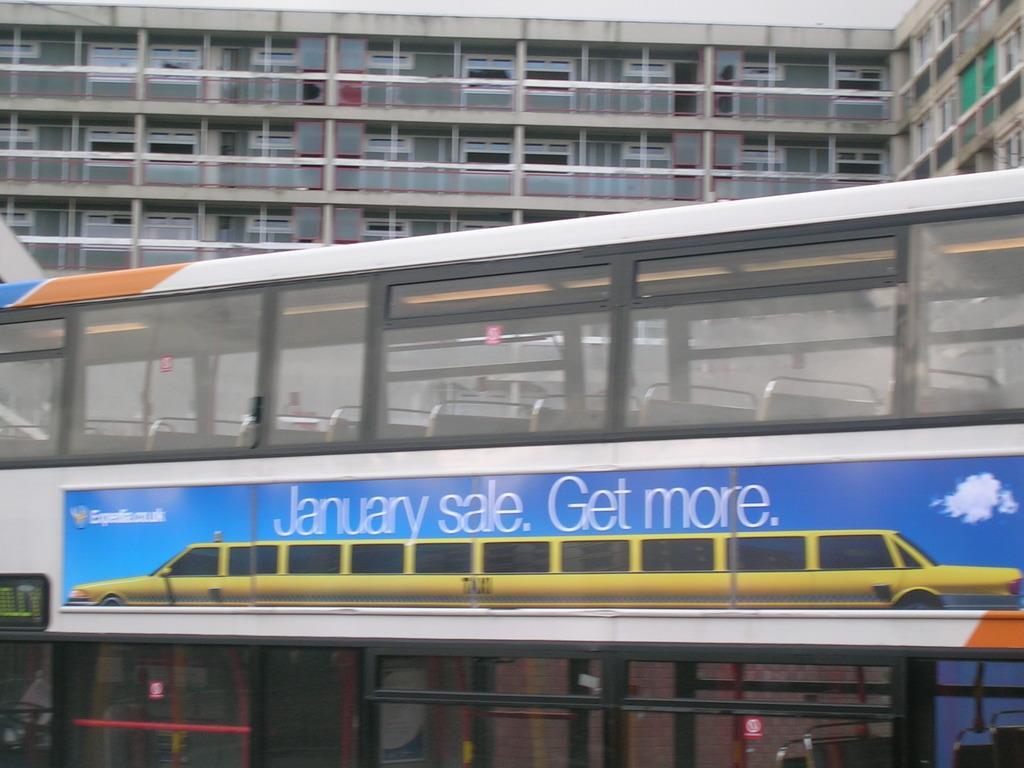How would you summarize this image in a sentence or two? In this image, we can see a vehicle. On the vehicle, there is a poster. Here we can see few rods, glass objects and digital screen. Background there is a building. Here we can see walls and windows. 